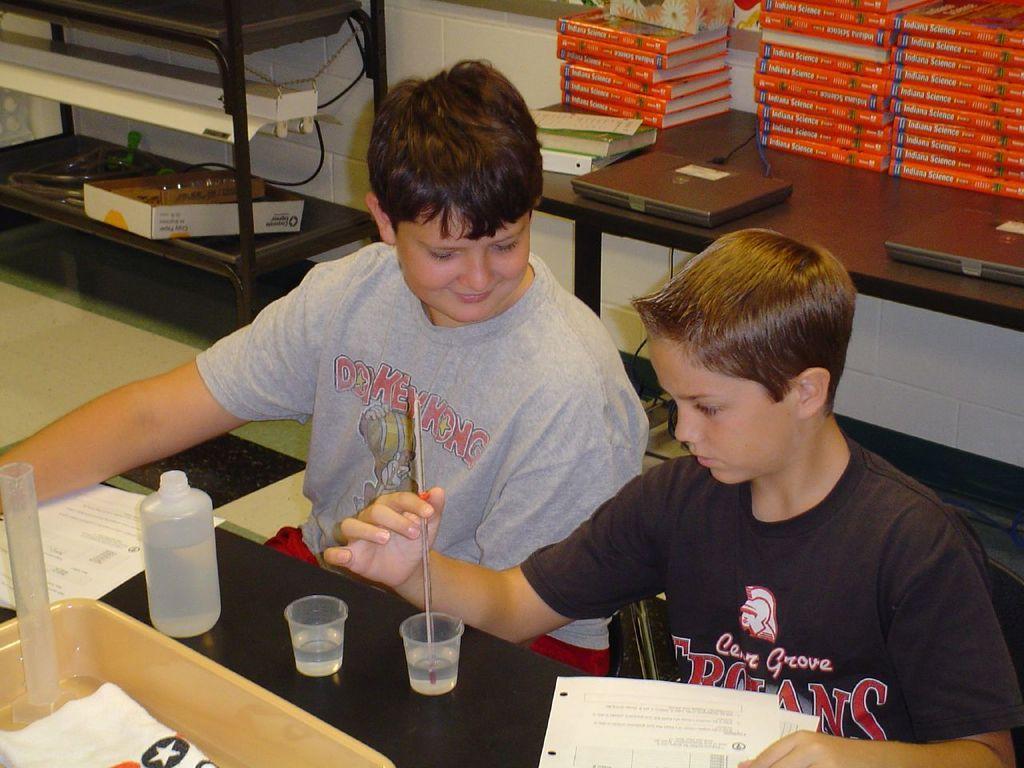In one or two sentences, can you explain what this image depicts? In the center we can see two persons were sitting. In front of them we can see the table,on table we can see some objects. Coming to background we can see one more table on table we can see books and tiles. Some more objects around them. 